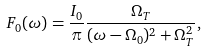Convert formula to latex. <formula><loc_0><loc_0><loc_500><loc_500>F _ { 0 } ( \omega ) = \frac { I _ { 0 } } { \pi } \frac { \Omega _ { T } } { ( \omega - \Omega _ { 0 } ) ^ { 2 } + \Omega _ { T } ^ { 2 } } ,</formula> 